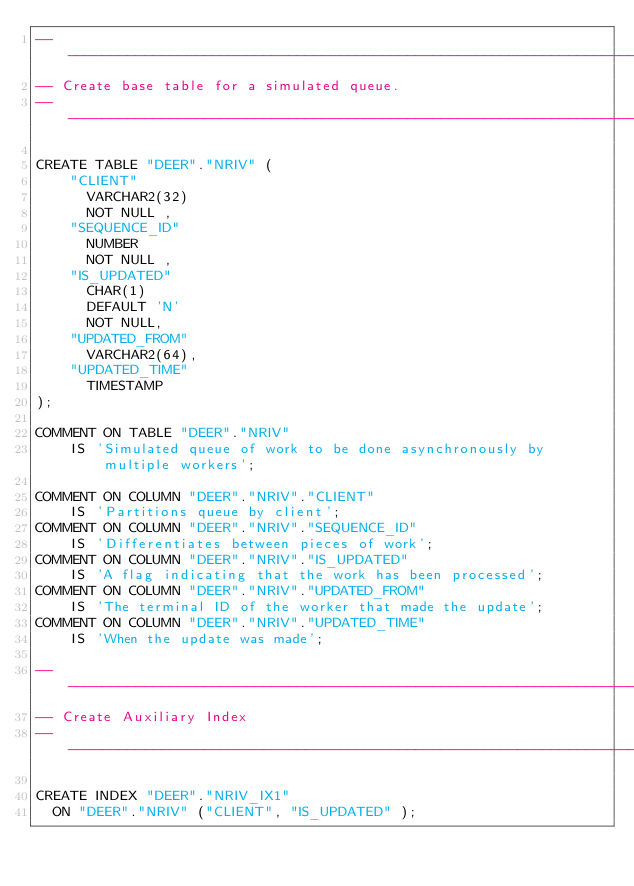Convert code to text. <code><loc_0><loc_0><loc_500><loc_500><_SQL_>-- ------------------------------------------------------------------------------
-- Create base table for a simulated queue.
-- ------------------------------------------------------------------------------

CREATE TABLE "DEER"."NRIV" (
    "CLIENT"
      VARCHAR2(32)
      NOT NULL ,
    "SEQUENCE_ID"
      NUMBER
      NOT NULL ,
    "IS_UPDATED"
      CHAR(1)
      DEFAULT 'N'
      NOT NULL,
    "UPDATED_FROM"
      VARCHAR2(64),
    "UPDATED_TIME"
      TIMESTAMP
);

COMMENT ON TABLE "DEER"."NRIV"
    IS 'Simulated queue of work to be done asynchronously by multiple workers';
    
COMMENT ON COLUMN "DEER"."NRIV"."CLIENT"
    IS 'Partitions queue by client';
COMMENT ON COLUMN "DEER"."NRIV"."SEQUENCE_ID"
    IS 'Differentiates between pieces of work';
COMMENT ON COLUMN "DEER"."NRIV"."IS_UPDATED"
    IS 'A flag indicating that the work has been processed';
COMMENT ON COLUMN "DEER"."NRIV"."UPDATED_FROM"
    IS 'The terminal ID of the worker that made the update';
COMMENT ON COLUMN "DEER"."NRIV"."UPDATED_TIME"
    IS 'When the update was made';

-- -----------------------------------------------------------------------------
-- Create Auxiliary Index
-- -----------------------------------------------------------------------------

CREATE INDEX "DEER"."NRIV_IX1"
  ON "DEER"."NRIV" ("CLIENT", "IS_UPDATED" );
</code> 